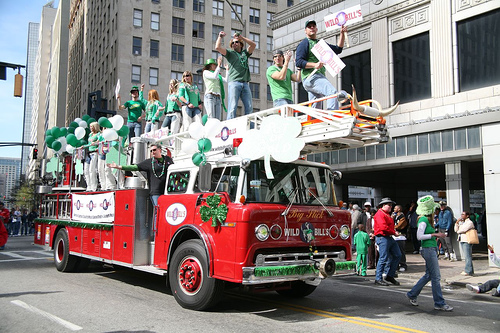<image>
Is there a man behind the fire truck? No. The man is not behind the fire truck. From this viewpoint, the man appears to be positioned elsewhere in the scene. Where is the window in relation to the board? Is it in front of the board? No. The window is not in front of the board. The spatial positioning shows a different relationship between these objects. 